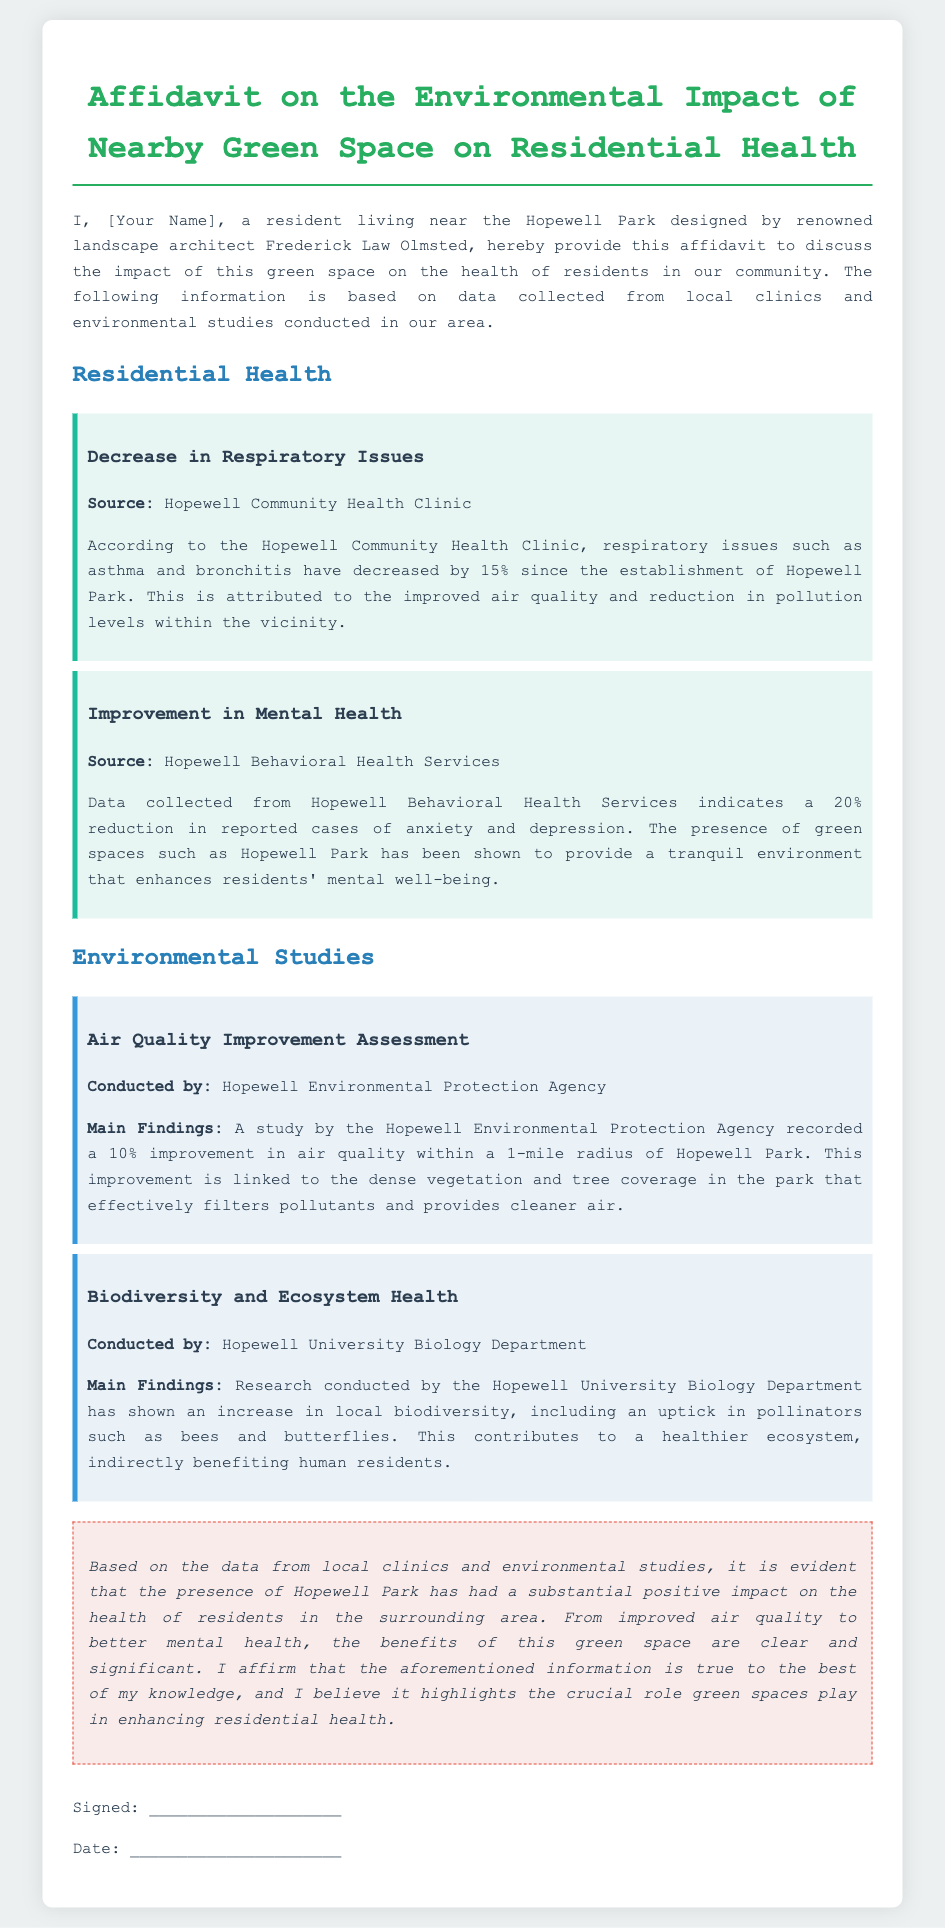what is the percentage decrease in respiratory issues? The document states that respiratory issues such as asthma and bronchitis have decreased by 15% since the establishment of Hopewell Park.
Answer: 15% what is the source of data for mental health improvement? The data collected for the improvement in mental health comes from Hopewell Behavioral Health Services.
Answer: Hopewell Behavioral Health Services what is the improvement in air quality recorded? The Hopewell Environmental Protection Agency recorded a 10% improvement in air quality within a 1-mile radius of Hopewell Park.
Answer: 10% who conducted the biodiversity study? The study on biodiversity and ecosystem health was conducted by the Hopewell University Biology Department.
Answer: Hopewell University Biology Department how much was the reduction in reported cases of anxiety and depression? According to the document, there was a 20% reduction in reported cases of anxiety and depression due to the presence of green spaces.
Answer: 20% what role do green spaces play according to the conclusion? The conclusion highlights that green spaces play a crucial role in enhancing residential health.
Answer: crucial role what is the main focus of the affidavit? The main focus of the affidavit is to discuss the impact of green spaces on the health of residents in the community.
Answer: impact on resident health what decreases have been reported at the Hopewell Community Health Clinic? The Hopewell Community Health Clinic reported a decrease in respiratory issues since the establishment of the park.
Answer: respiratory issues what is affirmed at the end of the affidavit? At the end of the affidavit, it is affirmed that the information provided is true to the best of the author's knowledge.
Answer: true to the best of my knowledge 